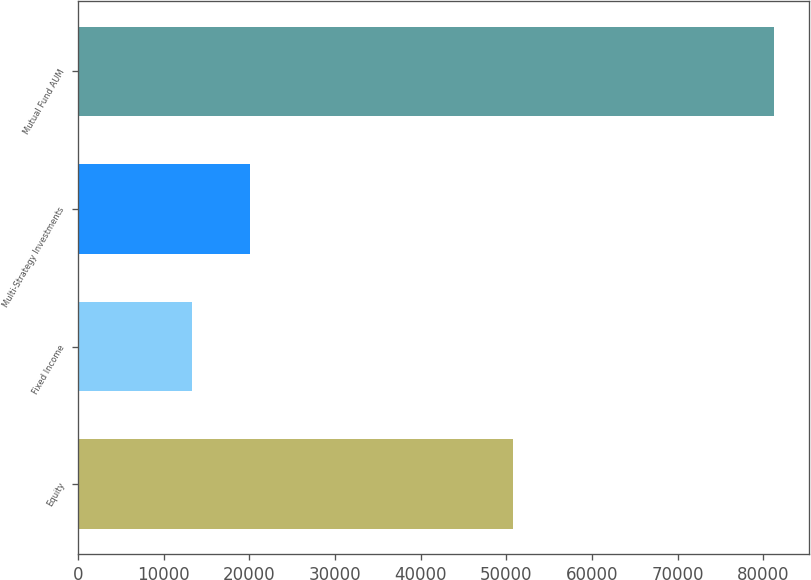Convert chart. <chart><loc_0><loc_0><loc_500><loc_500><bar_chart><fcel>Equity<fcel>Fixed Income<fcel>Multi-Strategy Investments<fcel>Mutual Fund AUM<nl><fcel>50826<fcel>13301<fcel>20100.7<fcel>81298<nl></chart> 